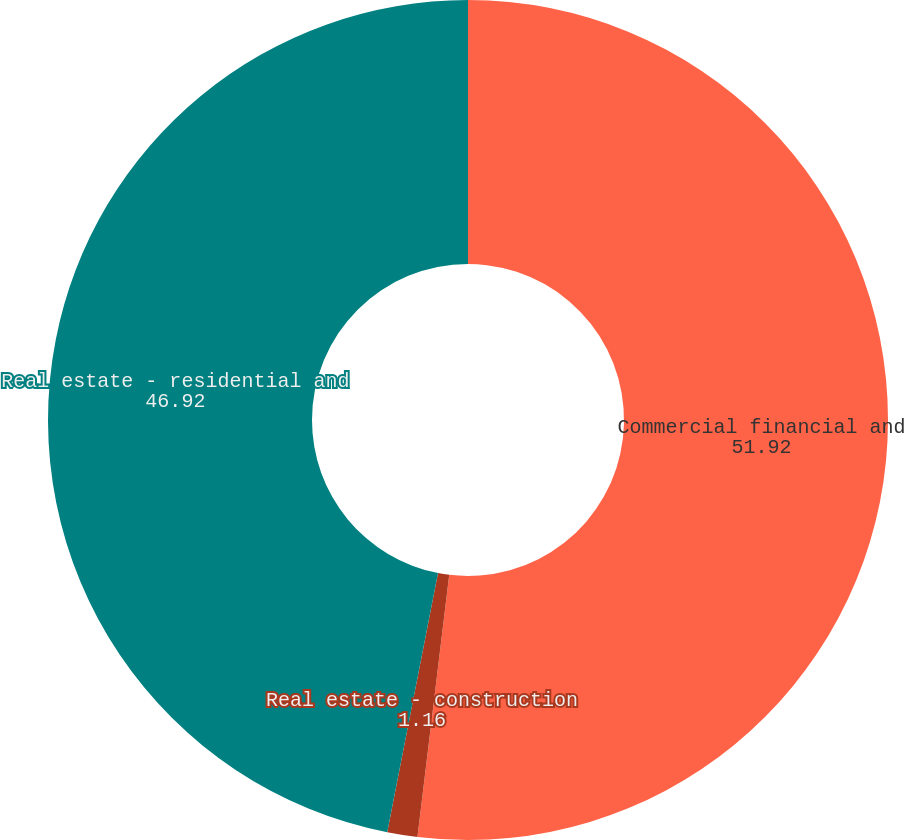<chart> <loc_0><loc_0><loc_500><loc_500><pie_chart><fcel>Commercial financial and<fcel>Real estate - construction<fcel>Real estate - residential and<nl><fcel>51.92%<fcel>1.16%<fcel>46.92%<nl></chart> 